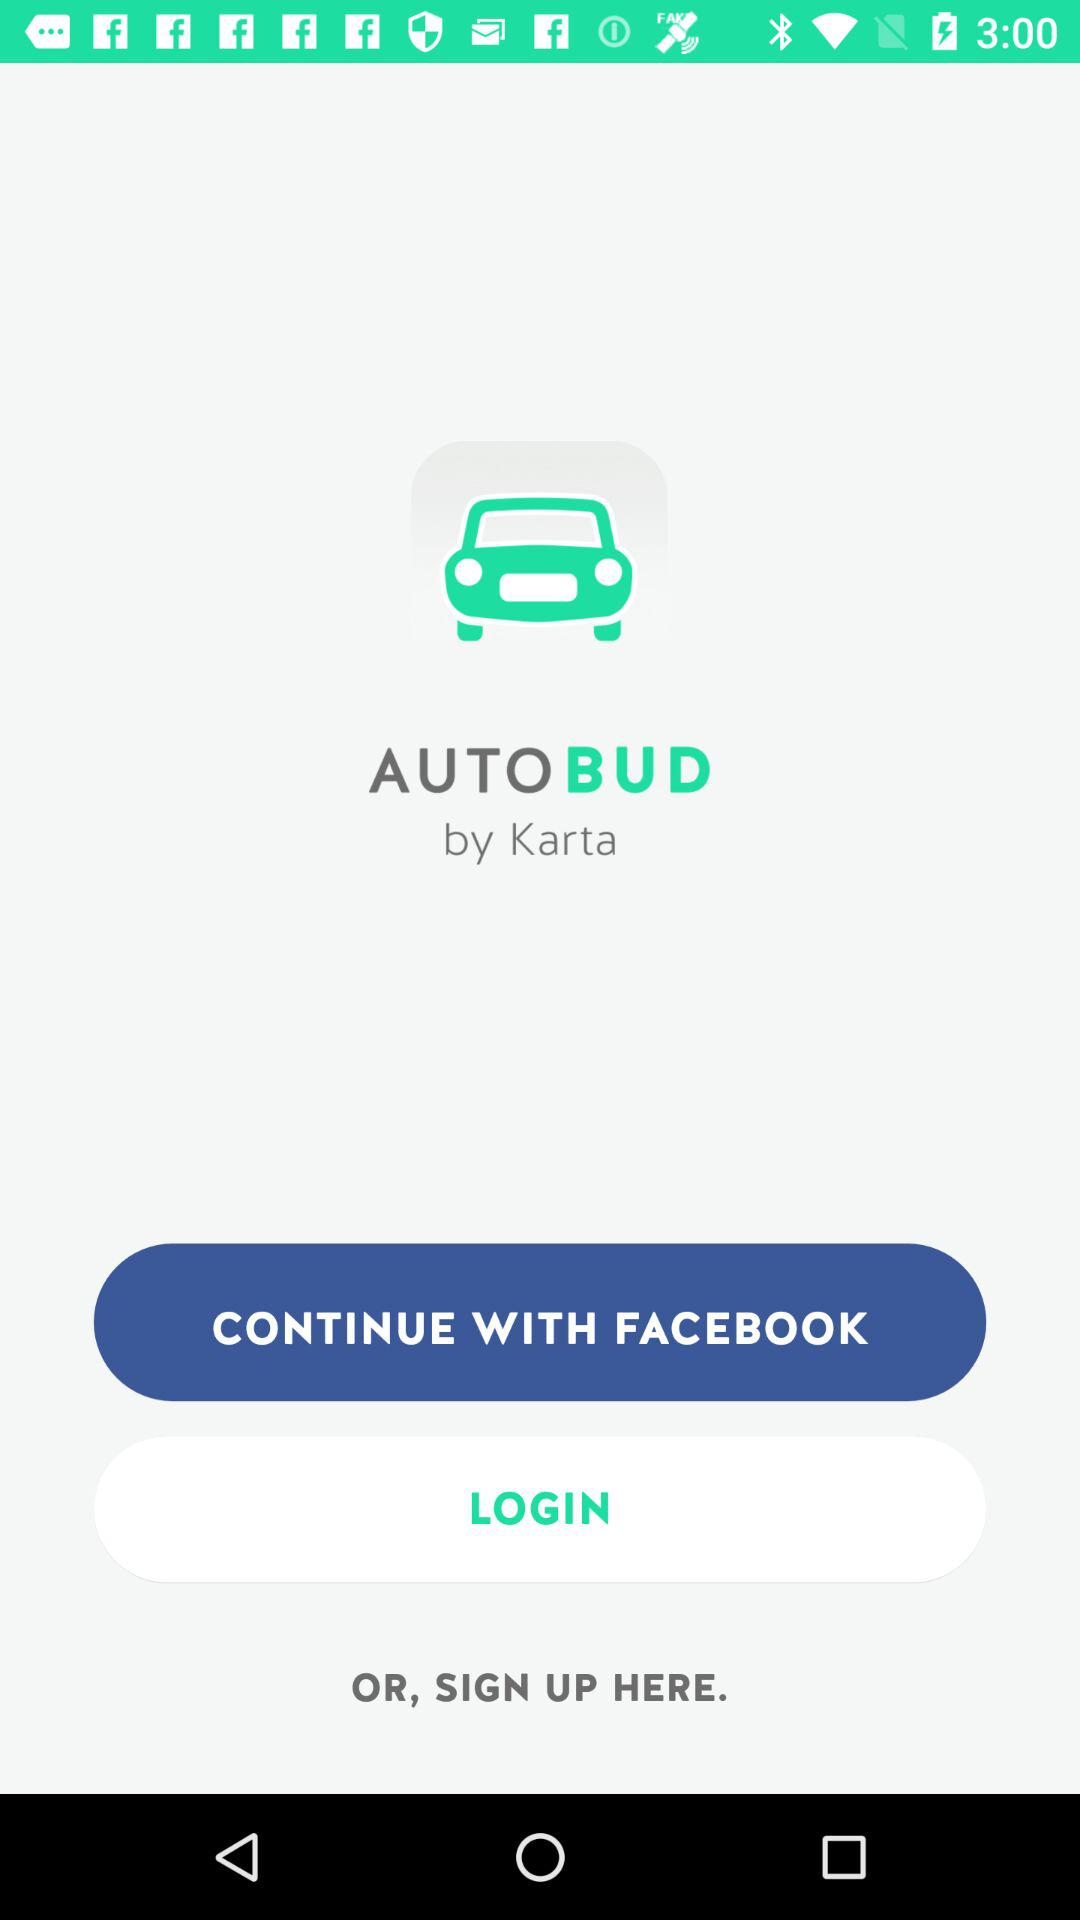What is the application name? The application name is "AUTOBUD". 